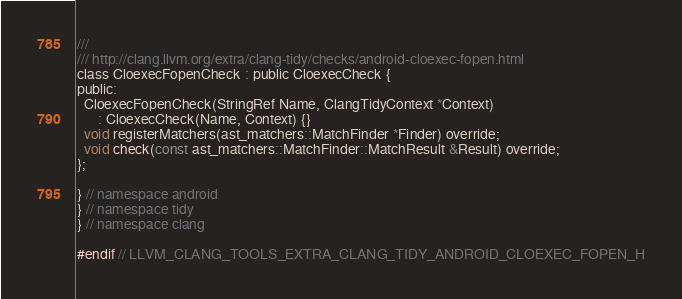<code> <loc_0><loc_0><loc_500><loc_500><_C_>///
/// http://clang.llvm.org/extra/clang-tidy/checks/android-cloexec-fopen.html
class CloexecFopenCheck : public CloexecCheck {
public:
  CloexecFopenCheck(StringRef Name, ClangTidyContext *Context)
      : CloexecCheck(Name, Context) {}
  void registerMatchers(ast_matchers::MatchFinder *Finder) override;
  void check(const ast_matchers::MatchFinder::MatchResult &Result) override;
};

} // namespace android
} // namespace tidy
} // namespace clang

#endif // LLVM_CLANG_TOOLS_EXTRA_CLANG_TIDY_ANDROID_CLOEXEC_FOPEN_H
</code> 